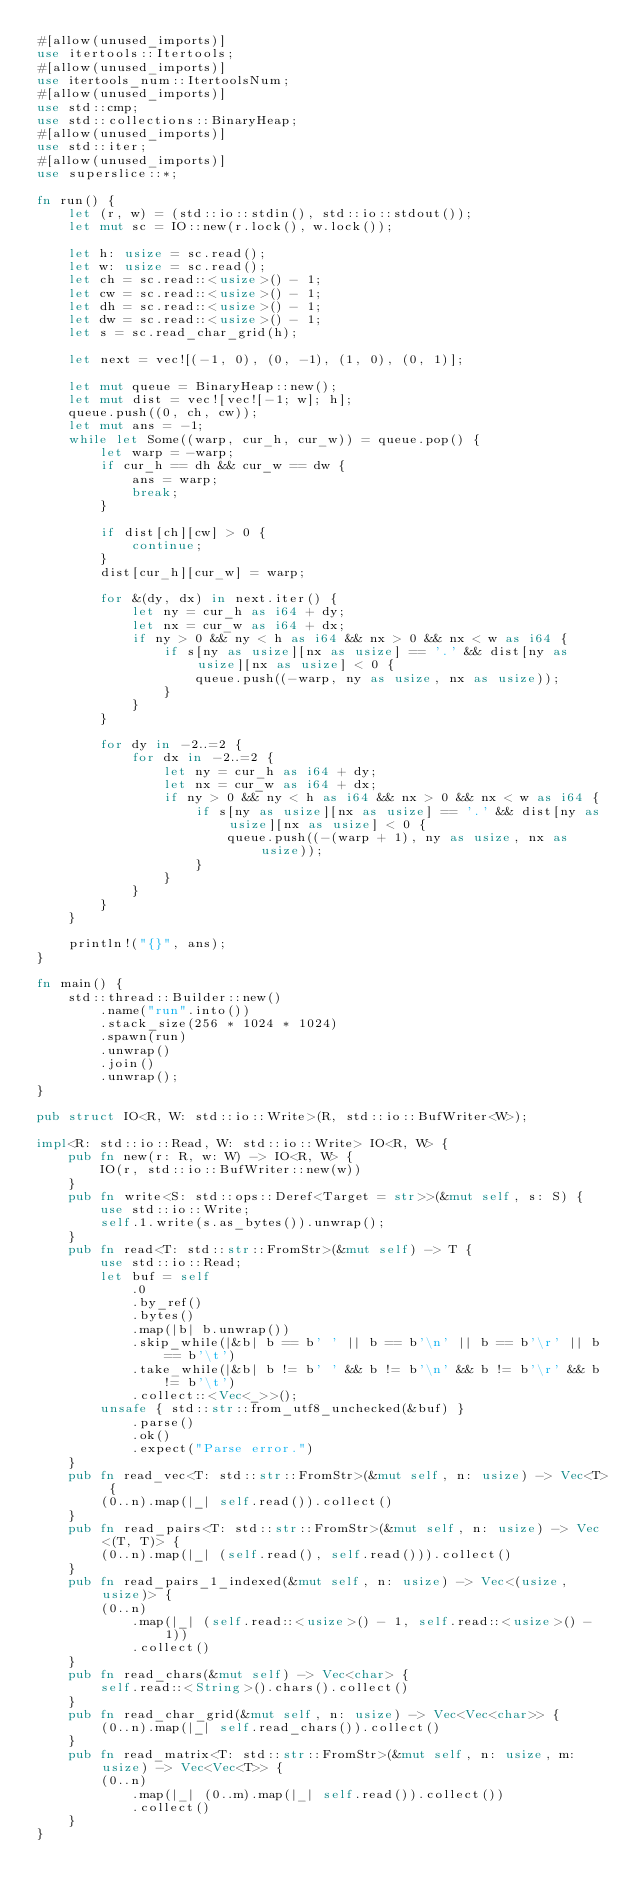<code> <loc_0><loc_0><loc_500><loc_500><_Rust_>#[allow(unused_imports)]
use itertools::Itertools;
#[allow(unused_imports)]
use itertools_num::ItertoolsNum;
#[allow(unused_imports)]
use std::cmp;
use std::collections::BinaryHeap;
#[allow(unused_imports)]
use std::iter;
#[allow(unused_imports)]
use superslice::*;

fn run() {
    let (r, w) = (std::io::stdin(), std::io::stdout());
    let mut sc = IO::new(r.lock(), w.lock());

    let h: usize = sc.read();
    let w: usize = sc.read();
    let ch = sc.read::<usize>() - 1;
    let cw = sc.read::<usize>() - 1;
    let dh = sc.read::<usize>() - 1;
    let dw = sc.read::<usize>() - 1;
    let s = sc.read_char_grid(h);

    let next = vec![(-1, 0), (0, -1), (1, 0), (0, 1)];

    let mut queue = BinaryHeap::new();
    let mut dist = vec![vec![-1; w]; h];
    queue.push((0, ch, cw));
    let mut ans = -1;
    while let Some((warp, cur_h, cur_w)) = queue.pop() {
        let warp = -warp;
        if cur_h == dh && cur_w == dw {
            ans = warp;
            break;
        }

        if dist[ch][cw] > 0 {
            continue;
        }
        dist[cur_h][cur_w] = warp;

        for &(dy, dx) in next.iter() {
            let ny = cur_h as i64 + dy;
            let nx = cur_w as i64 + dx;
            if ny > 0 && ny < h as i64 && nx > 0 && nx < w as i64 {
                if s[ny as usize][nx as usize] == '.' && dist[ny as usize][nx as usize] < 0 {
                    queue.push((-warp, ny as usize, nx as usize));
                }
            }
        }

        for dy in -2..=2 {
            for dx in -2..=2 {
                let ny = cur_h as i64 + dy;
                let nx = cur_w as i64 + dx;
                if ny > 0 && ny < h as i64 && nx > 0 && nx < w as i64 {
                    if s[ny as usize][nx as usize] == '.' && dist[ny as usize][nx as usize] < 0 {
                        queue.push((-(warp + 1), ny as usize, nx as usize));
                    }
                }
            }
        }
    }

    println!("{}", ans);
}

fn main() {
    std::thread::Builder::new()
        .name("run".into())
        .stack_size(256 * 1024 * 1024)
        .spawn(run)
        .unwrap()
        .join()
        .unwrap();
}

pub struct IO<R, W: std::io::Write>(R, std::io::BufWriter<W>);

impl<R: std::io::Read, W: std::io::Write> IO<R, W> {
    pub fn new(r: R, w: W) -> IO<R, W> {
        IO(r, std::io::BufWriter::new(w))
    }
    pub fn write<S: std::ops::Deref<Target = str>>(&mut self, s: S) {
        use std::io::Write;
        self.1.write(s.as_bytes()).unwrap();
    }
    pub fn read<T: std::str::FromStr>(&mut self) -> T {
        use std::io::Read;
        let buf = self
            .0
            .by_ref()
            .bytes()
            .map(|b| b.unwrap())
            .skip_while(|&b| b == b' ' || b == b'\n' || b == b'\r' || b == b'\t')
            .take_while(|&b| b != b' ' && b != b'\n' && b != b'\r' && b != b'\t')
            .collect::<Vec<_>>();
        unsafe { std::str::from_utf8_unchecked(&buf) }
            .parse()
            .ok()
            .expect("Parse error.")
    }
    pub fn read_vec<T: std::str::FromStr>(&mut self, n: usize) -> Vec<T> {
        (0..n).map(|_| self.read()).collect()
    }
    pub fn read_pairs<T: std::str::FromStr>(&mut self, n: usize) -> Vec<(T, T)> {
        (0..n).map(|_| (self.read(), self.read())).collect()
    }
    pub fn read_pairs_1_indexed(&mut self, n: usize) -> Vec<(usize, usize)> {
        (0..n)
            .map(|_| (self.read::<usize>() - 1, self.read::<usize>() - 1))
            .collect()
    }
    pub fn read_chars(&mut self) -> Vec<char> {
        self.read::<String>().chars().collect()
    }
    pub fn read_char_grid(&mut self, n: usize) -> Vec<Vec<char>> {
        (0..n).map(|_| self.read_chars()).collect()
    }
    pub fn read_matrix<T: std::str::FromStr>(&mut self, n: usize, m: usize) -> Vec<Vec<T>> {
        (0..n)
            .map(|_| (0..m).map(|_| self.read()).collect())
            .collect()
    }
}
</code> 